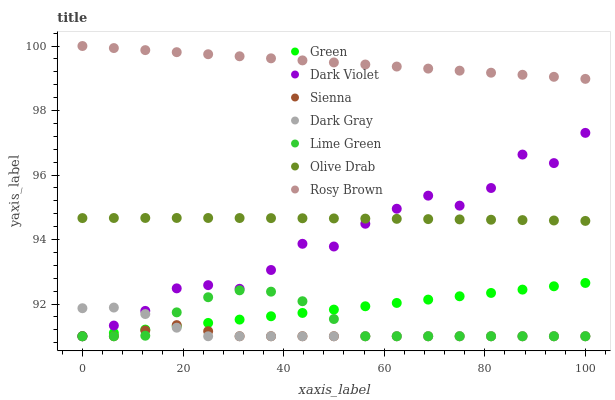Does Sienna have the minimum area under the curve?
Answer yes or no. Yes. Does Rosy Brown have the maximum area under the curve?
Answer yes or no. Yes. Does Dark Violet have the minimum area under the curve?
Answer yes or no. No. Does Dark Violet have the maximum area under the curve?
Answer yes or no. No. Is Green the smoothest?
Answer yes or no. Yes. Is Dark Violet the roughest?
Answer yes or no. Yes. Is Rosy Brown the smoothest?
Answer yes or no. No. Is Rosy Brown the roughest?
Answer yes or no. No. Does Dark Gray have the lowest value?
Answer yes or no. Yes. Does Rosy Brown have the lowest value?
Answer yes or no. No. Does Rosy Brown have the highest value?
Answer yes or no. Yes. Does Dark Violet have the highest value?
Answer yes or no. No. Is Green less than Rosy Brown?
Answer yes or no. Yes. Is Rosy Brown greater than Dark Violet?
Answer yes or no. Yes. Does Dark Violet intersect Olive Drab?
Answer yes or no. Yes. Is Dark Violet less than Olive Drab?
Answer yes or no. No. Is Dark Violet greater than Olive Drab?
Answer yes or no. No. Does Green intersect Rosy Brown?
Answer yes or no. No. 